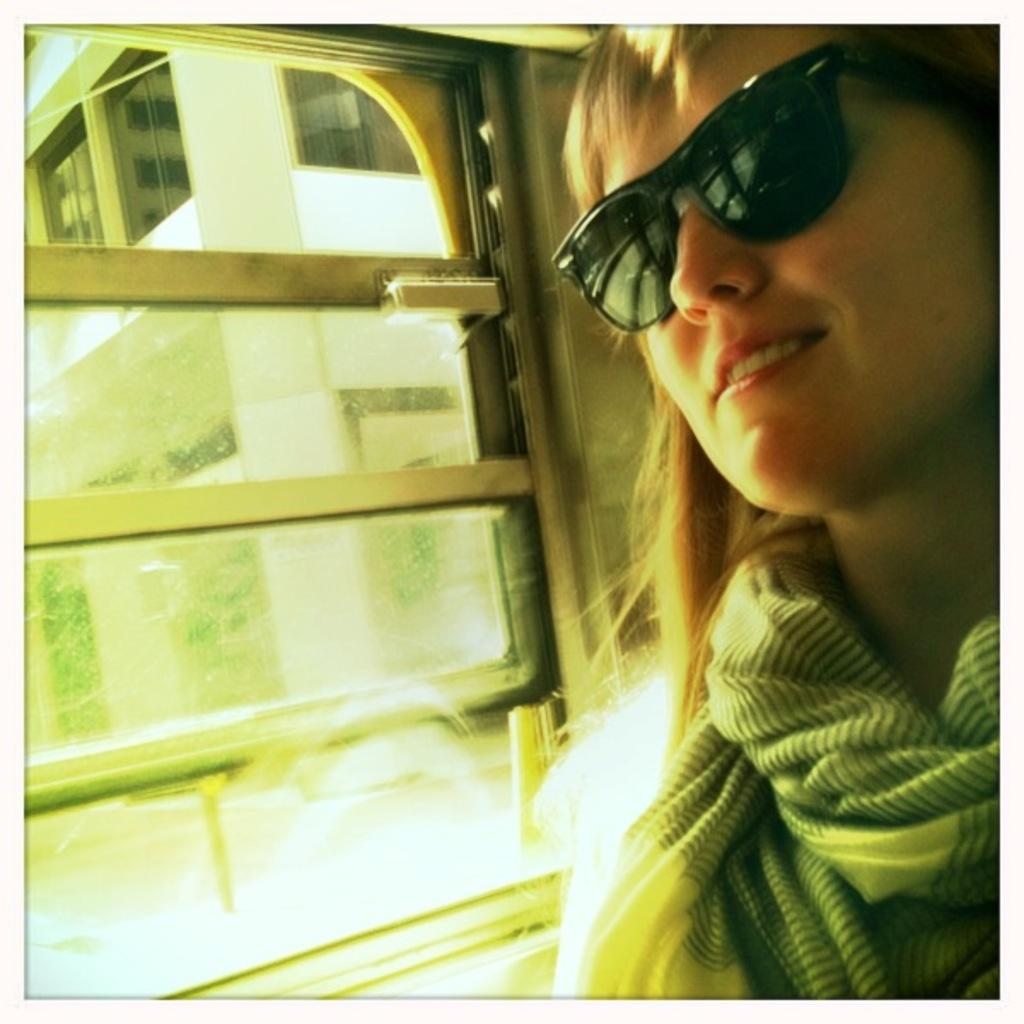Who is present in the image? There is a woman in the image. What is the woman's facial expression? The woman is smiling. What accessory is the woman wearing? The woman is wearing spectacles. What can be seen near the woman in the image? There is a window beside the woman. What is visible in the background of the image? There is a building visible in the background of the image. What is the woman writing in the image? There is no indication that the woman is writing in the image. 